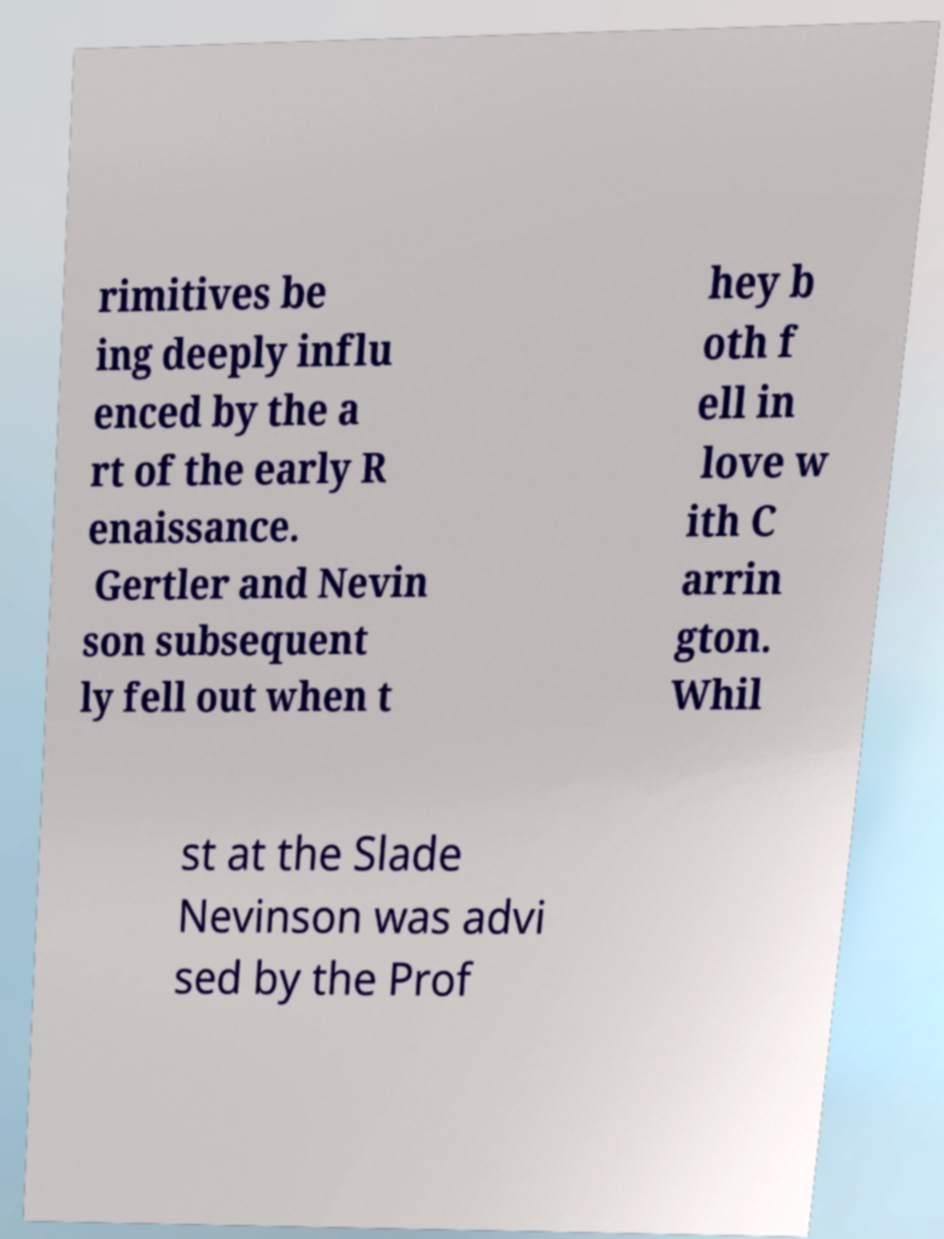Can you read and provide the text displayed in the image?This photo seems to have some interesting text. Can you extract and type it out for me? rimitives be ing deeply influ enced by the a rt of the early R enaissance. Gertler and Nevin son subsequent ly fell out when t hey b oth f ell in love w ith C arrin gton. Whil st at the Slade Nevinson was advi sed by the Prof 